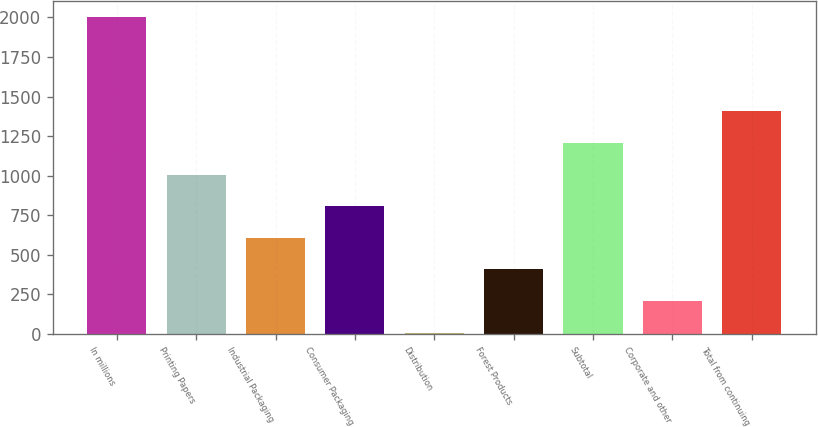<chart> <loc_0><loc_0><loc_500><loc_500><bar_chart><fcel>In millions<fcel>Printing Papers<fcel>Industrial Packaging<fcel>Consumer Packaging<fcel>Distribution<fcel>Forest Products<fcel>Subtotal<fcel>Corporate and other<fcel>Total from continuing<nl><fcel>2005<fcel>1007<fcel>607.8<fcel>807.4<fcel>9<fcel>408.2<fcel>1206.6<fcel>208.6<fcel>1406.2<nl></chart> 